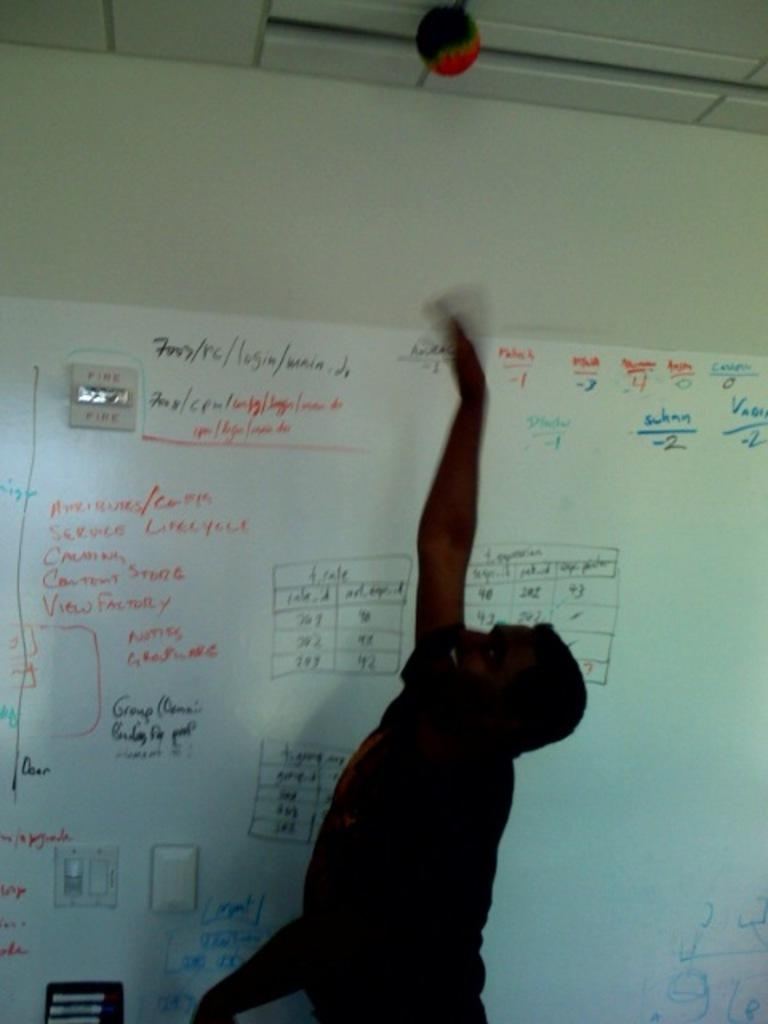<image>
Render a clear and concise summary of the photo. The boys vertical jump was -2 and according to the chart, below average. 